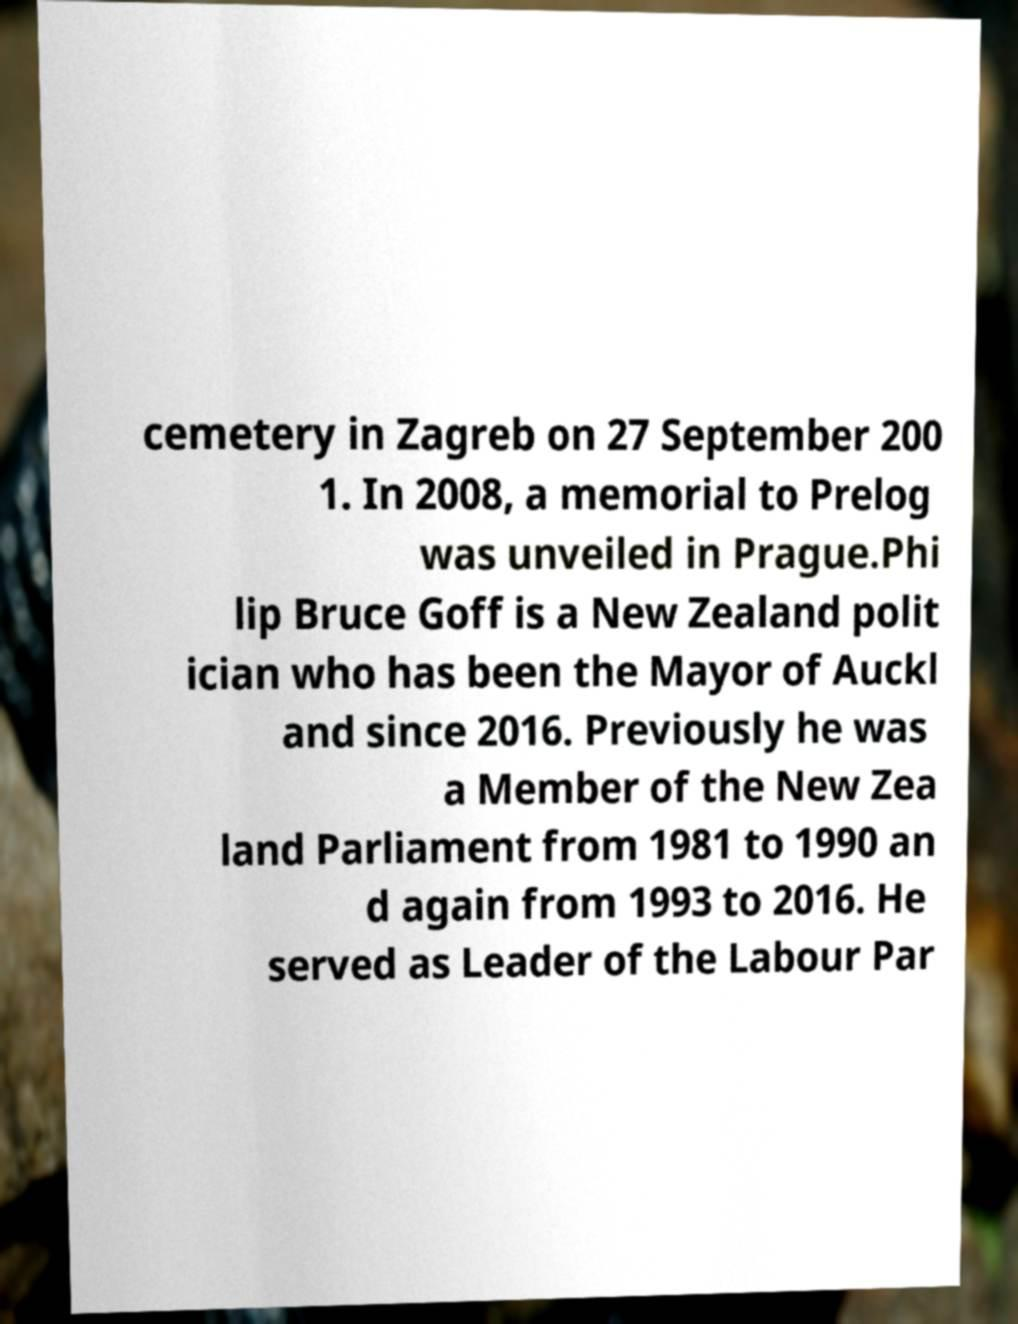Could you assist in decoding the text presented in this image and type it out clearly? cemetery in Zagreb on 27 September 200 1. In 2008, a memorial to Prelog was unveiled in Prague.Phi lip Bruce Goff is a New Zealand polit ician who has been the Mayor of Auckl and since 2016. Previously he was a Member of the New Zea land Parliament from 1981 to 1990 an d again from 1993 to 2016. He served as Leader of the Labour Par 